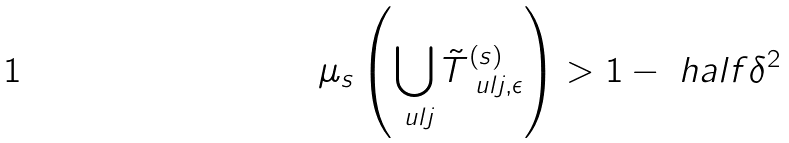<formula> <loc_0><loc_0><loc_500><loc_500>\mu _ { s } \left ( \bigcup _ { \ u l { j } } { \tilde { T } } _ { \ u l { j } , \epsilon } ^ { ( s ) } \right ) > 1 - \ h a l f \delta ^ { 2 }</formula> 